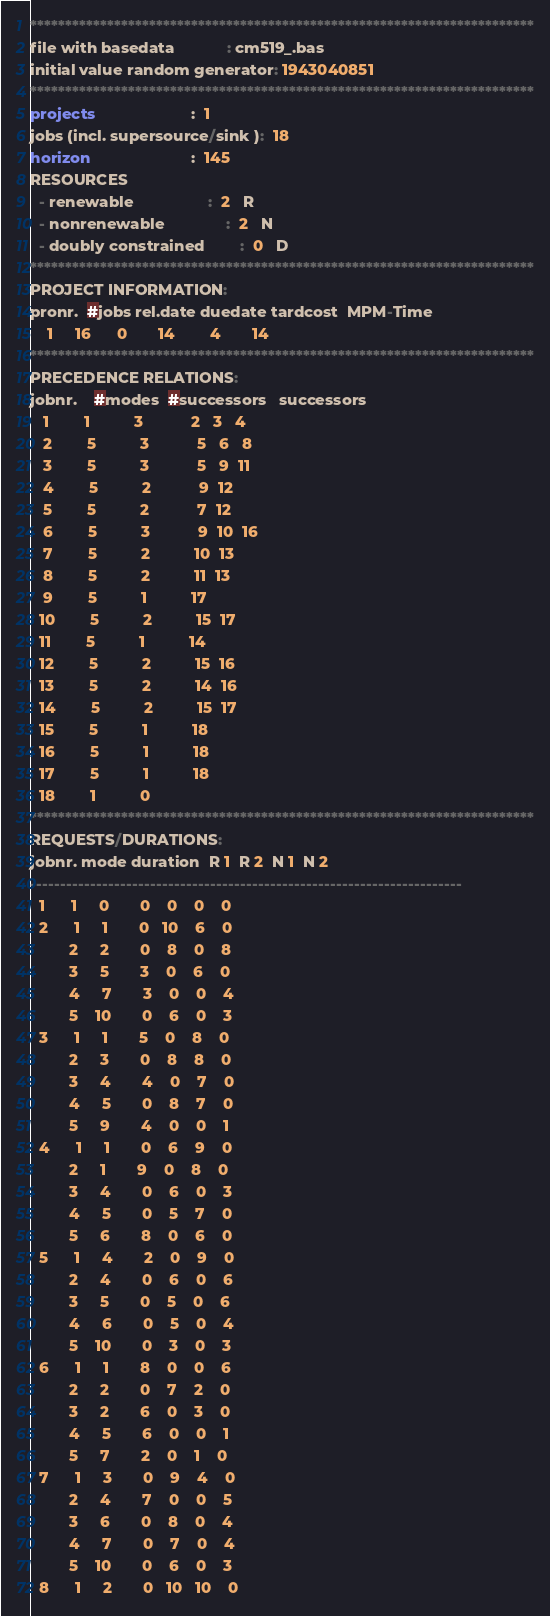Convert code to text. <code><loc_0><loc_0><loc_500><loc_500><_ObjectiveC_>************************************************************************
file with basedata            : cm519_.bas
initial value random generator: 1943040851
************************************************************************
projects                      :  1
jobs (incl. supersource/sink ):  18
horizon                       :  145
RESOURCES
  - renewable                 :  2   R
  - nonrenewable              :  2   N
  - doubly constrained        :  0   D
************************************************************************
PROJECT INFORMATION:
pronr.  #jobs rel.date duedate tardcost  MPM-Time
    1     16      0       14        4       14
************************************************************************
PRECEDENCE RELATIONS:
jobnr.    #modes  #successors   successors
   1        1          3           2   3   4
   2        5          3           5   6   8
   3        5          3           5   9  11
   4        5          2           9  12
   5        5          2           7  12
   6        5          3           9  10  16
   7        5          2          10  13
   8        5          2          11  13
   9        5          1          17
  10        5          2          15  17
  11        5          1          14
  12        5          2          15  16
  13        5          2          14  16
  14        5          2          15  17
  15        5          1          18
  16        5          1          18
  17        5          1          18
  18        1          0        
************************************************************************
REQUESTS/DURATIONS:
jobnr. mode duration  R 1  R 2  N 1  N 2
------------------------------------------------------------------------
  1      1     0       0    0    0    0
  2      1     1       0   10    6    0
         2     2       0    8    0    8
         3     5       3    0    6    0
         4     7       3    0    0    4
         5    10       0    6    0    3
  3      1     1       5    0    8    0
         2     3       0    8    8    0
         3     4       4    0    7    0
         4     5       0    8    7    0
         5     9       4    0    0    1
  4      1     1       0    6    9    0
         2     1       9    0    8    0
         3     4       0    6    0    3
         4     5       0    5    7    0
         5     6       8    0    6    0
  5      1     4       2    0    9    0
         2     4       0    6    0    6
         3     5       0    5    0    6
         4     6       0    5    0    4
         5    10       0    3    0    3
  6      1     1       8    0    0    6
         2     2       0    7    2    0
         3     2       6    0    3    0
         4     5       6    0    0    1
         5     7       2    0    1    0
  7      1     3       0    9    4    0
         2     4       7    0    0    5
         3     6       0    8    0    4
         4     7       0    7    0    4
         5    10       0    6    0    3
  8      1     2       0   10   10    0</code> 